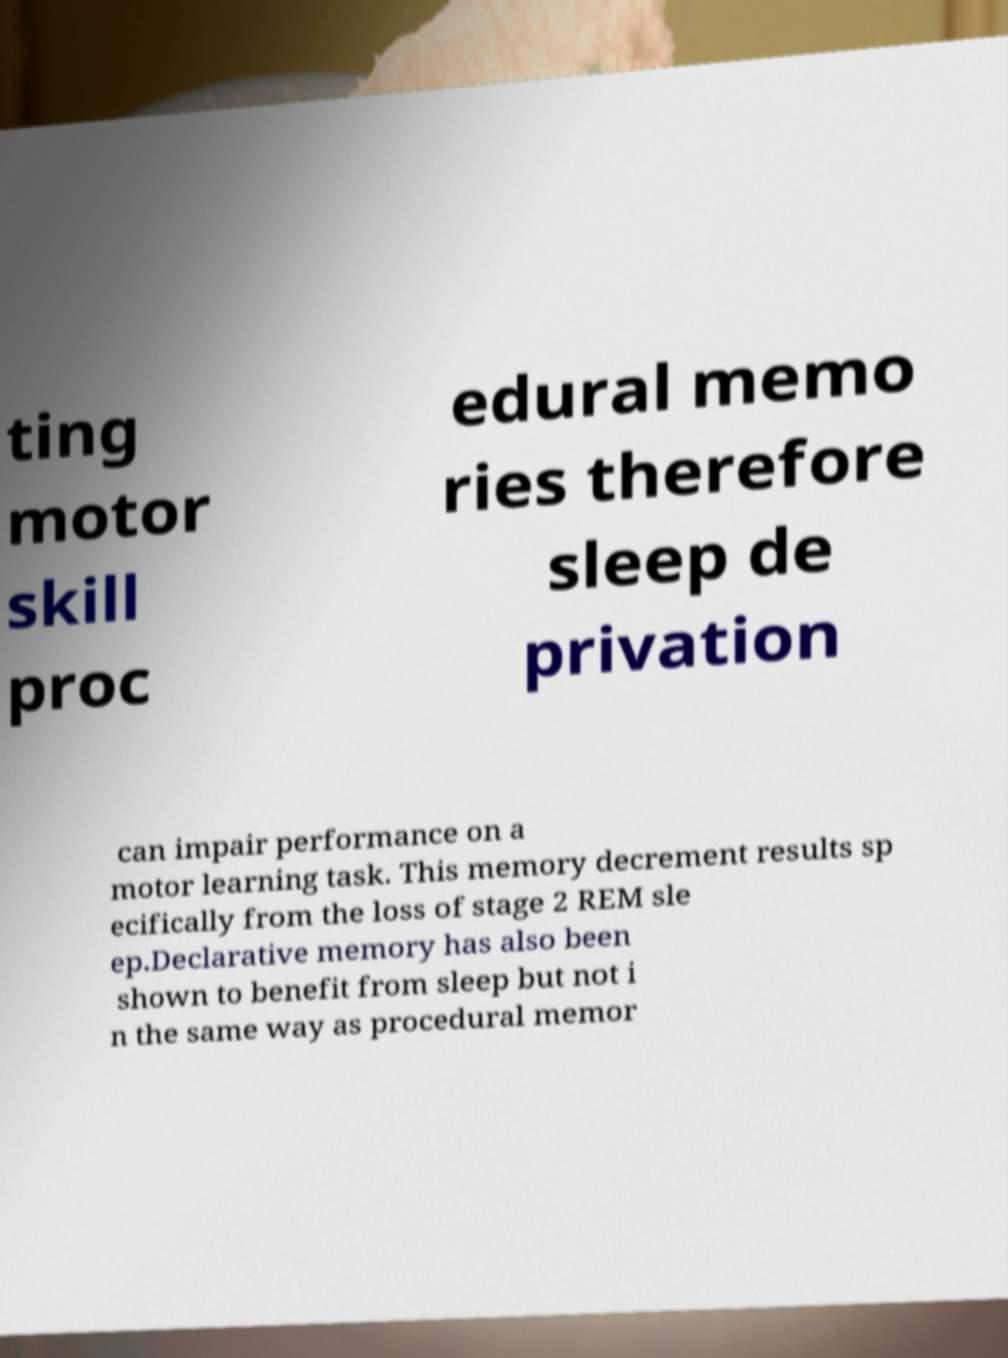Please read and relay the text visible in this image. What does it say? ting motor skill proc edural memo ries therefore sleep de privation can impair performance on a motor learning task. This memory decrement results sp ecifically from the loss of stage 2 REM sle ep.Declarative memory has also been shown to benefit from sleep but not i n the same way as procedural memor 